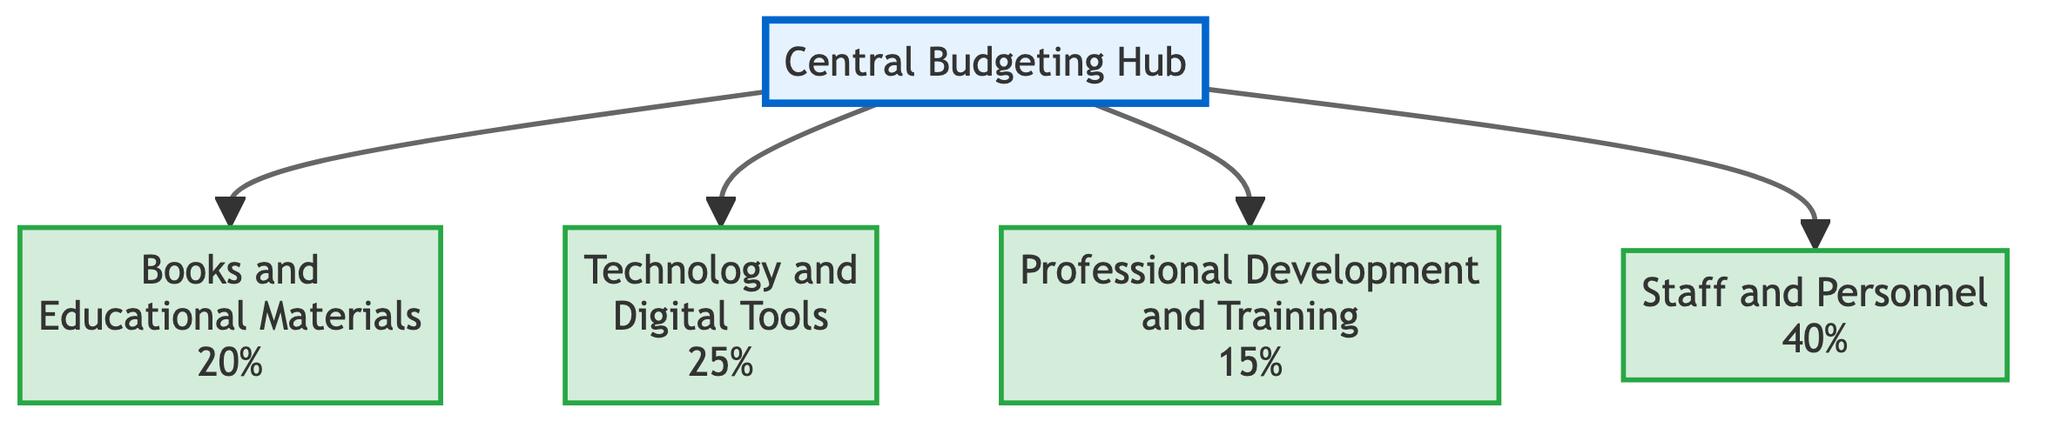What is the total percentage allocated for Books and Technology? To find the total percentage for Books and Technology, we look at the allocations for each. Books account for 20% and Technology accounts for 25%. Adding these values together, we get 20% + 25%, which equals 45%.
Answer: 45% Which block has the highest allocation percentage? By inspecting the allocation percentages of all blocks, we see that Personnel has an allocation of 40%, which is higher than the other allocations: 20% for Books, 25% for Technology, and 15% for Training. Therefore, Personnel has the highest allocation.
Answer: Personnel How many blocks are connected to the Central Budgeting Hub? The Central Budgeting Hub connects to four distinct blocks: Books, Technology, Training, and Personnel. Counting these connections, we find there are four blocks connected to the hub.
Answer: 4 What percentage is allocated for Professional Development and Training? The allocation for Professional Development and Training is indicated directly in the diagram, which shows a specific allocation of 15%. This provides the answer directly without further calculation.
Answer: 15% Which block corresponds to the expenditure for technology? The block labeled "Technology and Digital Tools" directly represents the expenditure for technology. It's identified clearly by its label in the diagram.
Answer: Technology and Digital Tools What percentage of the budget is dedicated to hiring specialized language teachers? Hiring specialized language teachers falls under the "Staff and Personnel" block, which shows an allocation percentage of 40%. Thus, this is the specific amount dedicated to hiring these staff.
Answer: 40% Which blocks are grouped under the allocation category, and what percentage do they represent in total? The blocks under the allocation category include Books (20%), Technology (25%), Training (15%), and Personnel (40%). Summing these percentages, we calculate 20% + 25% + 15% + 40% = 100%. So there are four blocks representing a total of 100% in the allocation category.
Answer: 100% Which variables make up the school's budget specifically for language support services? The variables that make up the school's budget for language support services consist of four blocks: Books, Technology, Professional Development and Training, and Staff and Personnel. These are the components outlined in the diagram.
Answer: Books, Technology, Professional Development and Training, Staff and Personnel 